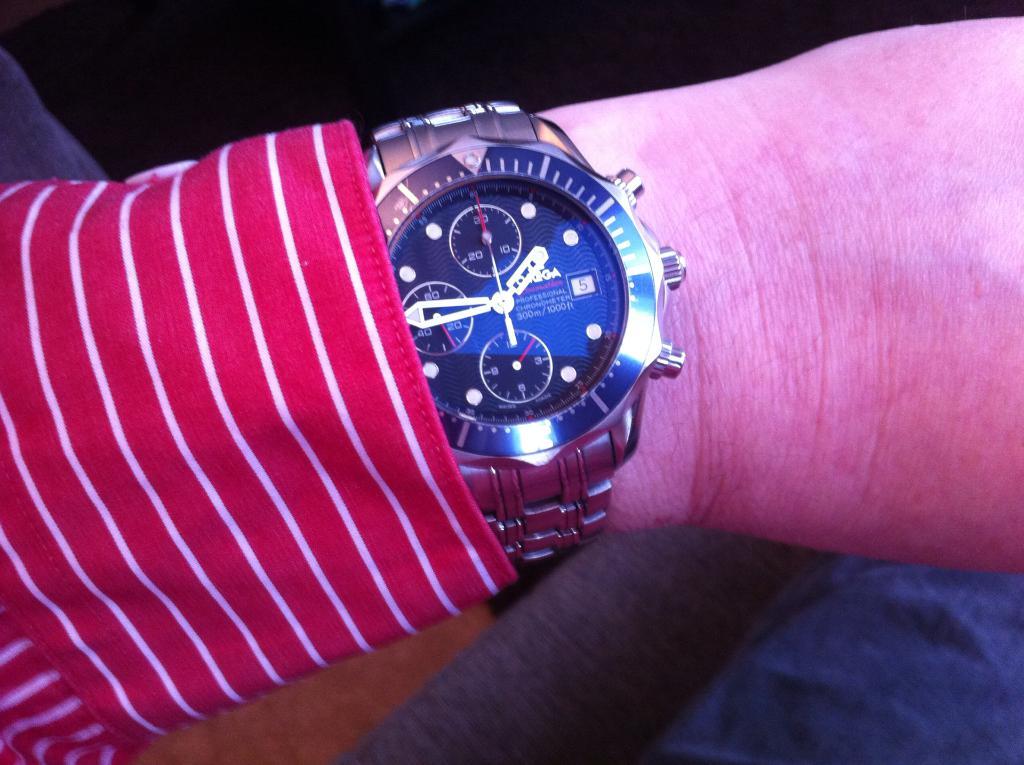What time is it?
Offer a terse response. 1:45. 